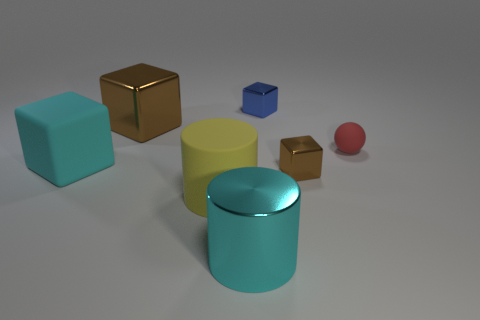Add 1 large red metallic cylinders. How many objects exist? 8 Subtract all big rubber blocks. How many blocks are left? 3 Subtract all brown cylinders. How many brown blocks are left? 2 Subtract all blue cubes. How many cubes are left? 3 Subtract 1 balls. How many balls are left? 0 Subtract all balls. How many objects are left? 6 Subtract all cyan spheres. Subtract all blue cylinders. How many spheres are left? 1 Subtract all large cyan matte things. Subtract all shiny cubes. How many objects are left? 3 Add 1 rubber objects. How many rubber objects are left? 4 Add 5 cyan rubber spheres. How many cyan rubber spheres exist? 5 